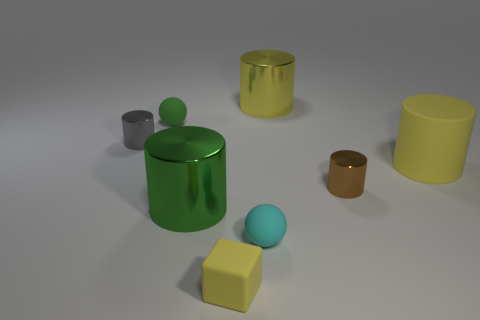Is the large cylinder on the left side of the small yellow cube made of the same material as the small green sphere?
Provide a succinct answer. No. How many small cyan objects have the same material as the tiny gray thing?
Your answer should be compact. 0. Is the number of yellow matte objects that are in front of the cyan ball greater than the number of small cyan matte cylinders?
Your answer should be compact. Yes. What size is the metallic object that is the same color as the tiny cube?
Give a very brief answer. Large. Is there a gray shiny thing that has the same shape as the tiny brown thing?
Ensure brevity in your answer.  Yes. What number of things are large purple rubber spheres or gray metallic cylinders?
Provide a succinct answer. 1. How many small green rubber spheres are behind the big metal thing that is in front of the tiny brown shiny object that is on the right side of the small gray cylinder?
Keep it short and to the point. 1. There is another object that is the same shape as the cyan matte thing; what is its material?
Your answer should be very brief. Rubber. There is a cylinder that is both behind the tiny brown shiny thing and left of the yellow matte block; what is it made of?
Provide a short and direct response. Metal. Are there fewer shiny things on the left side of the tiny cyan thing than things that are left of the small brown metal object?
Your answer should be very brief. Yes. 